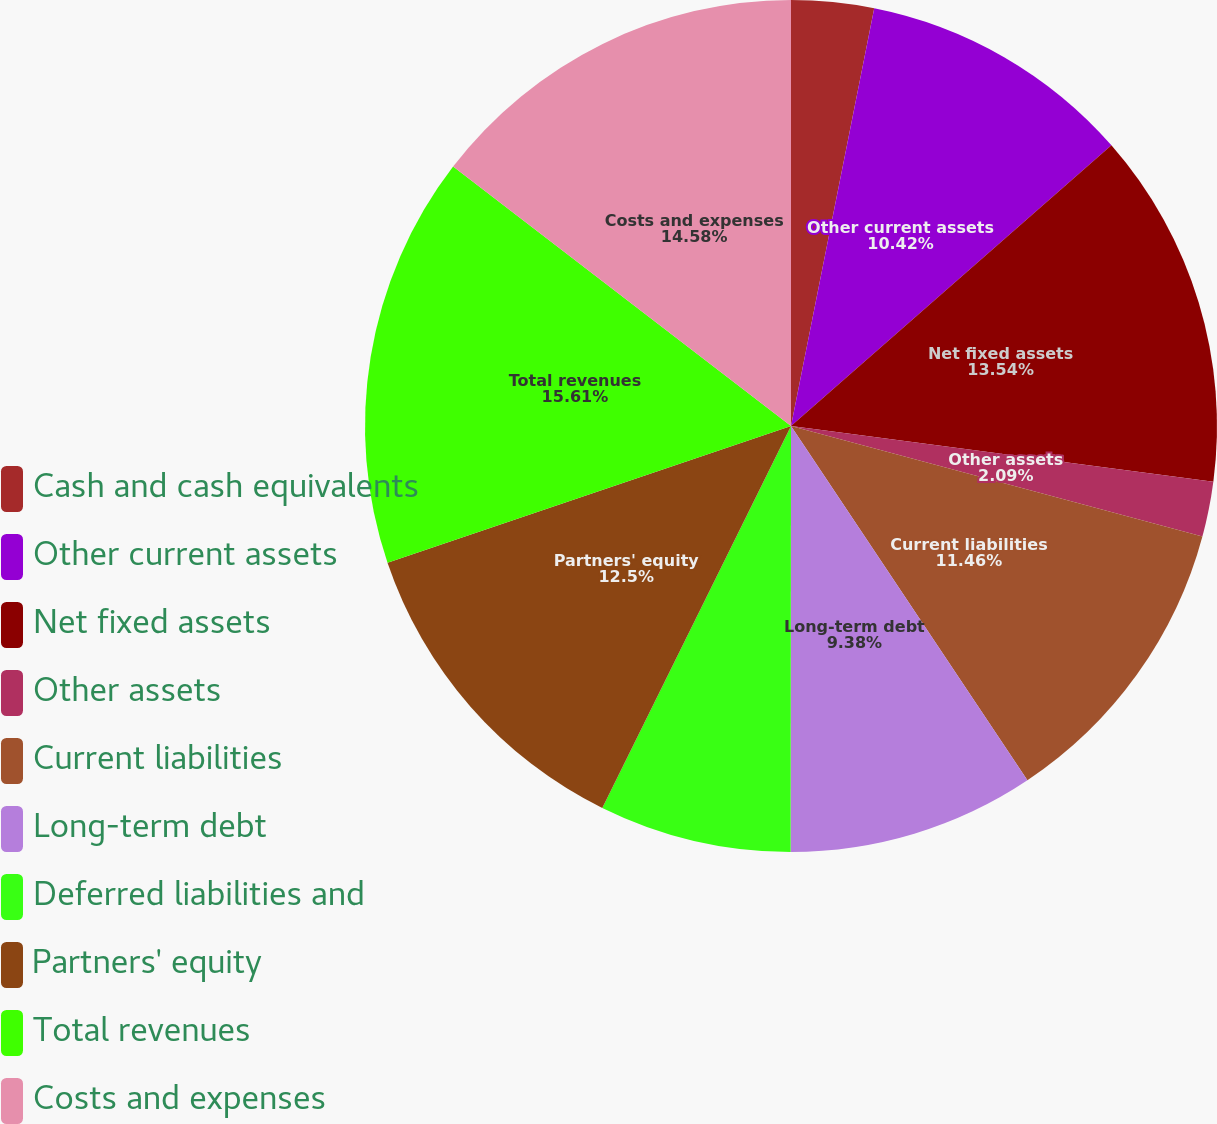Convert chart. <chart><loc_0><loc_0><loc_500><loc_500><pie_chart><fcel>Cash and cash equivalents<fcel>Other current assets<fcel>Net fixed assets<fcel>Other assets<fcel>Current liabilities<fcel>Long-term debt<fcel>Deferred liabilities and<fcel>Partners' equity<fcel>Total revenues<fcel>Costs and expenses<nl><fcel>3.13%<fcel>10.42%<fcel>13.54%<fcel>2.09%<fcel>11.46%<fcel>9.38%<fcel>7.29%<fcel>12.5%<fcel>15.62%<fcel>14.58%<nl></chart> 